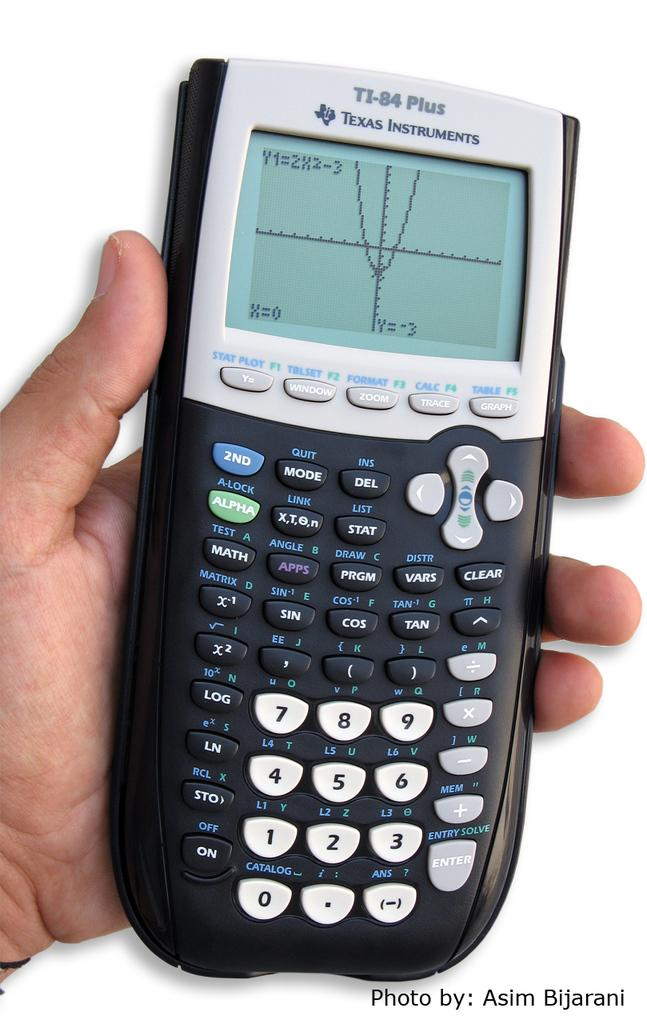What can be seen in the image? There is a person's hand in the image. What is the hand holding? The hand is holding a calculator. What type of doll is sitting on the cabbage in the image? There is no doll or cabbage present in the image; it only features a person's hand holding a calculator. 